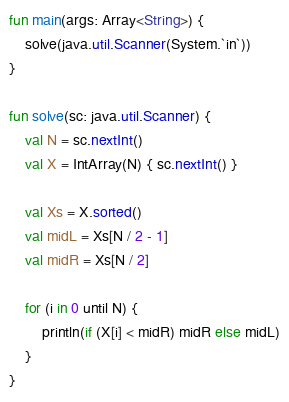Convert code to text. <code><loc_0><loc_0><loc_500><loc_500><_Kotlin_>fun main(args: Array<String>) {
    solve(java.util.Scanner(System.`in`))
}

fun solve(sc: java.util.Scanner) {
    val N = sc.nextInt()
    val X = IntArray(N) { sc.nextInt() }

    val Xs = X.sorted()
    val midL = Xs[N / 2 - 1]
    val midR = Xs[N / 2]

    for (i in 0 until N) {
        println(if (X[i] < midR) midR else midL)
    }
}
</code> 